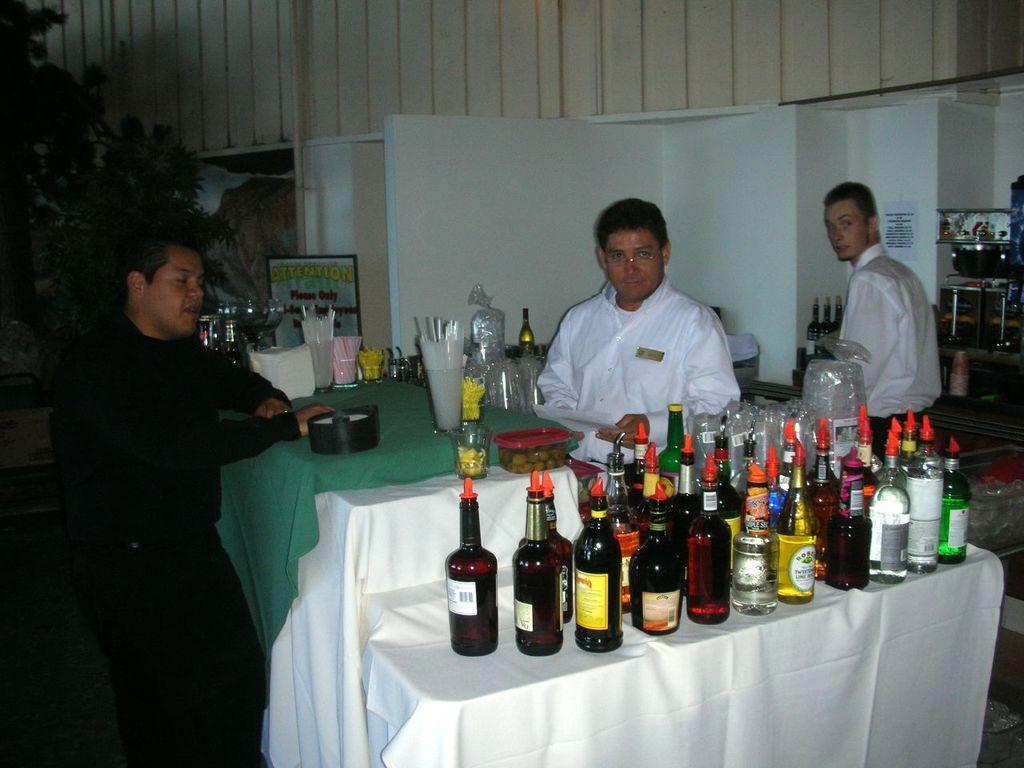Could you give a brief overview of what you see in this image? In this image I see 3 men in which these 2 are wearing white dress and this man is wearing black dress and there are tables in front of them on which there are bottles, straws, glasses, box and few things. In the background I see the wall, few more bottles over here and a plant. 